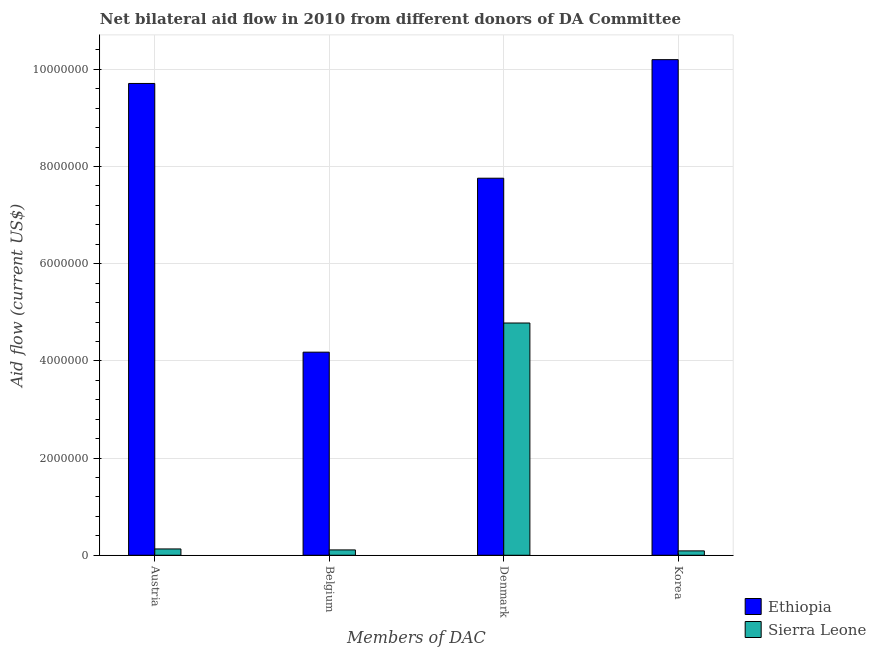Are the number of bars on each tick of the X-axis equal?
Your answer should be compact. Yes. What is the amount of aid given by denmark in Sierra Leone?
Offer a terse response. 4.78e+06. Across all countries, what is the maximum amount of aid given by belgium?
Ensure brevity in your answer.  4.18e+06. Across all countries, what is the minimum amount of aid given by korea?
Ensure brevity in your answer.  9.00e+04. In which country was the amount of aid given by denmark maximum?
Offer a terse response. Ethiopia. In which country was the amount of aid given by denmark minimum?
Your response must be concise. Sierra Leone. What is the total amount of aid given by austria in the graph?
Provide a short and direct response. 9.84e+06. What is the difference between the amount of aid given by belgium in Sierra Leone and that in Ethiopia?
Make the answer very short. -4.07e+06. What is the difference between the amount of aid given by austria in Sierra Leone and the amount of aid given by korea in Ethiopia?
Provide a succinct answer. -1.01e+07. What is the average amount of aid given by denmark per country?
Offer a very short reply. 6.27e+06. What is the difference between the amount of aid given by austria and amount of aid given by belgium in Ethiopia?
Your response must be concise. 5.53e+06. In how many countries, is the amount of aid given by korea greater than 2000000 US$?
Your answer should be very brief. 1. What is the ratio of the amount of aid given by korea in Sierra Leone to that in Ethiopia?
Offer a very short reply. 0.01. What is the difference between the highest and the second highest amount of aid given by austria?
Your answer should be very brief. 9.58e+06. What is the difference between the highest and the lowest amount of aid given by belgium?
Offer a very short reply. 4.07e+06. Is the sum of the amount of aid given by denmark in Sierra Leone and Ethiopia greater than the maximum amount of aid given by belgium across all countries?
Your response must be concise. Yes. What does the 2nd bar from the left in Austria represents?
Ensure brevity in your answer.  Sierra Leone. What does the 2nd bar from the right in Austria represents?
Offer a very short reply. Ethiopia. Is it the case that in every country, the sum of the amount of aid given by austria and amount of aid given by belgium is greater than the amount of aid given by denmark?
Provide a short and direct response. No. Are all the bars in the graph horizontal?
Your answer should be very brief. No. How many countries are there in the graph?
Make the answer very short. 2. Does the graph contain any zero values?
Your answer should be very brief. No. How many legend labels are there?
Ensure brevity in your answer.  2. How are the legend labels stacked?
Make the answer very short. Vertical. What is the title of the graph?
Give a very brief answer. Net bilateral aid flow in 2010 from different donors of DA Committee. Does "Lower middle income" appear as one of the legend labels in the graph?
Your answer should be very brief. No. What is the label or title of the X-axis?
Provide a short and direct response. Members of DAC. What is the label or title of the Y-axis?
Offer a very short reply. Aid flow (current US$). What is the Aid flow (current US$) of Ethiopia in Austria?
Provide a short and direct response. 9.71e+06. What is the Aid flow (current US$) of Sierra Leone in Austria?
Your answer should be compact. 1.30e+05. What is the Aid flow (current US$) of Ethiopia in Belgium?
Your answer should be compact. 4.18e+06. What is the Aid flow (current US$) of Sierra Leone in Belgium?
Give a very brief answer. 1.10e+05. What is the Aid flow (current US$) of Ethiopia in Denmark?
Offer a very short reply. 7.76e+06. What is the Aid flow (current US$) in Sierra Leone in Denmark?
Your response must be concise. 4.78e+06. What is the Aid flow (current US$) of Ethiopia in Korea?
Your answer should be compact. 1.02e+07. Across all Members of DAC, what is the maximum Aid flow (current US$) of Ethiopia?
Provide a short and direct response. 1.02e+07. Across all Members of DAC, what is the maximum Aid flow (current US$) of Sierra Leone?
Give a very brief answer. 4.78e+06. Across all Members of DAC, what is the minimum Aid flow (current US$) of Ethiopia?
Ensure brevity in your answer.  4.18e+06. Across all Members of DAC, what is the minimum Aid flow (current US$) of Sierra Leone?
Provide a succinct answer. 9.00e+04. What is the total Aid flow (current US$) of Ethiopia in the graph?
Provide a short and direct response. 3.18e+07. What is the total Aid flow (current US$) in Sierra Leone in the graph?
Your answer should be compact. 5.11e+06. What is the difference between the Aid flow (current US$) in Ethiopia in Austria and that in Belgium?
Give a very brief answer. 5.53e+06. What is the difference between the Aid flow (current US$) of Ethiopia in Austria and that in Denmark?
Your answer should be compact. 1.95e+06. What is the difference between the Aid flow (current US$) in Sierra Leone in Austria and that in Denmark?
Your answer should be compact. -4.65e+06. What is the difference between the Aid flow (current US$) in Ethiopia in Austria and that in Korea?
Your response must be concise. -4.90e+05. What is the difference between the Aid flow (current US$) of Ethiopia in Belgium and that in Denmark?
Your answer should be compact. -3.58e+06. What is the difference between the Aid flow (current US$) of Sierra Leone in Belgium and that in Denmark?
Your answer should be compact. -4.67e+06. What is the difference between the Aid flow (current US$) in Ethiopia in Belgium and that in Korea?
Offer a terse response. -6.02e+06. What is the difference between the Aid flow (current US$) in Ethiopia in Denmark and that in Korea?
Make the answer very short. -2.44e+06. What is the difference between the Aid flow (current US$) of Sierra Leone in Denmark and that in Korea?
Your answer should be compact. 4.69e+06. What is the difference between the Aid flow (current US$) in Ethiopia in Austria and the Aid flow (current US$) in Sierra Leone in Belgium?
Provide a succinct answer. 9.60e+06. What is the difference between the Aid flow (current US$) of Ethiopia in Austria and the Aid flow (current US$) of Sierra Leone in Denmark?
Offer a very short reply. 4.93e+06. What is the difference between the Aid flow (current US$) in Ethiopia in Austria and the Aid flow (current US$) in Sierra Leone in Korea?
Your answer should be very brief. 9.62e+06. What is the difference between the Aid flow (current US$) of Ethiopia in Belgium and the Aid flow (current US$) of Sierra Leone in Denmark?
Give a very brief answer. -6.00e+05. What is the difference between the Aid flow (current US$) of Ethiopia in Belgium and the Aid flow (current US$) of Sierra Leone in Korea?
Your answer should be very brief. 4.09e+06. What is the difference between the Aid flow (current US$) in Ethiopia in Denmark and the Aid flow (current US$) in Sierra Leone in Korea?
Offer a very short reply. 7.67e+06. What is the average Aid flow (current US$) in Ethiopia per Members of DAC?
Give a very brief answer. 7.96e+06. What is the average Aid flow (current US$) in Sierra Leone per Members of DAC?
Provide a short and direct response. 1.28e+06. What is the difference between the Aid flow (current US$) of Ethiopia and Aid flow (current US$) of Sierra Leone in Austria?
Ensure brevity in your answer.  9.58e+06. What is the difference between the Aid flow (current US$) of Ethiopia and Aid flow (current US$) of Sierra Leone in Belgium?
Provide a short and direct response. 4.07e+06. What is the difference between the Aid flow (current US$) of Ethiopia and Aid flow (current US$) of Sierra Leone in Denmark?
Provide a short and direct response. 2.98e+06. What is the difference between the Aid flow (current US$) of Ethiopia and Aid flow (current US$) of Sierra Leone in Korea?
Offer a very short reply. 1.01e+07. What is the ratio of the Aid flow (current US$) in Ethiopia in Austria to that in Belgium?
Your response must be concise. 2.32. What is the ratio of the Aid flow (current US$) of Sierra Leone in Austria to that in Belgium?
Give a very brief answer. 1.18. What is the ratio of the Aid flow (current US$) in Ethiopia in Austria to that in Denmark?
Offer a very short reply. 1.25. What is the ratio of the Aid flow (current US$) in Sierra Leone in Austria to that in Denmark?
Your answer should be compact. 0.03. What is the ratio of the Aid flow (current US$) of Sierra Leone in Austria to that in Korea?
Keep it short and to the point. 1.44. What is the ratio of the Aid flow (current US$) in Ethiopia in Belgium to that in Denmark?
Offer a terse response. 0.54. What is the ratio of the Aid flow (current US$) of Sierra Leone in Belgium to that in Denmark?
Make the answer very short. 0.02. What is the ratio of the Aid flow (current US$) in Ethiopia in Belgium to that in Korea?
Provide a short and direct response. 0.41. What is the ratio of the Aid flow (current US$) in Sierra Leone in Belgium to that in Korea?
Give a very brief answer. 1.22. What is the ratio of the Aid flow (current US$) of Ethiopia in Denmark to that in Korea?
Make the answer very short. 0.76. What is the ratio of the Aid flow (current US$) of Sierra Leone in Denmark to that in Korea?
Make the answer very short. 53.11. What is the difference between the highest and the second highest Aid flow (current US$) of Sierra Leone?
Make the answer very short. 4.65e+06. What is the difference between the highest and the lowest Aid flow (current US$) in Ethiopia?
Make the answer very short. 6.02e+06. What is the difference between the highest and the lowest Aid flow (current US$) of Sierra Leone?
Offer a very short reply. 4.69e+06. 